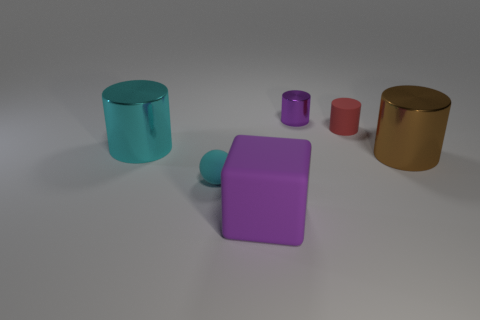What is the size of the thing that is the same color as the block?
Provide a short and direct response. Small. What material is the large brown object that is the same shape as the tiny purple metal object?
Provide a short and direct response. Metal. What number of cyan things are either metal cylinders or cylinders?
Make the answer very short. 1. Are there an equal number of purple rubber blocks that are right of the red cylinder and large matte things that are behind the purple block?
Your response must be concise. Yes. The big metallic cylinder that is on the right side of the matte object that is behind the big metallic thing right of the purple shiny thing is what color?
Provide a succinct answer. Brown. Are there any other things of the same color as the small metallic object?
Your response must be concise. Yes. What is the shape of the big thing that is the same color as the small metallic thing?
Offer a very short reply. Cube. What is the size of the shiny object to the left of the ball?
Provide a short and direct response. Large. What shape is the other metal thing that is the same size as the brown thing?
Offer a terse response. Cylinder. Is the small object in front of the brown cylinder made of the same material as the big thing that is on the right side of the purple cube?
Give a very brief answer. No. 